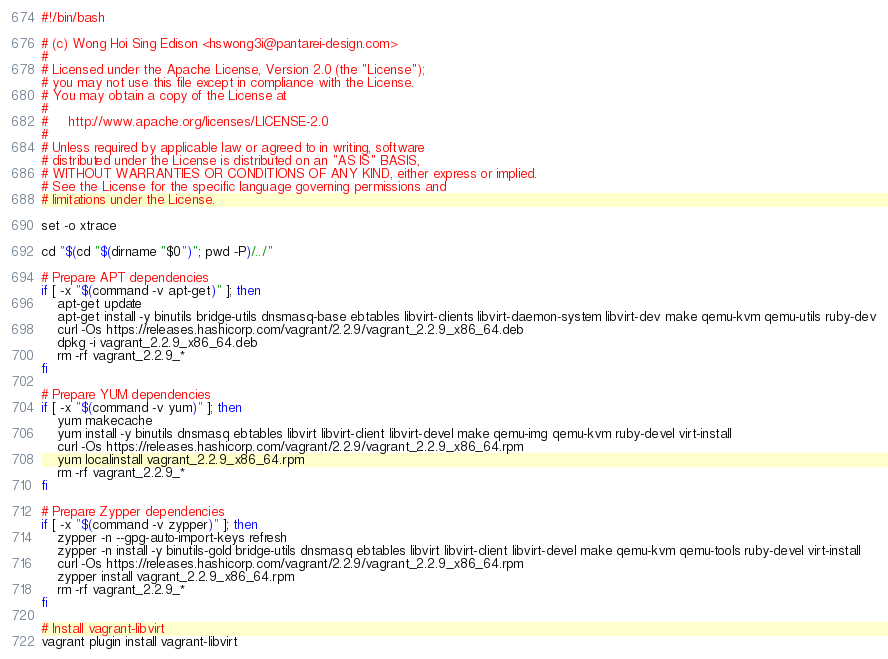Convert code to text. <code><loc_0><loc_0><loc_500><loc_500><_Bash_>#!/bin/bash

# (c) Wong Hoi Sing Edison <hswong3i@pantarei-design.com>
#
# Licensed under the Apache License, Version 2.0 (the "License");
# you may not use this file except in compliance with the License.
# You may obtain a copy of the License at
#
#     http://www.apache.org/licenses/LICENSE-2.0
#
# Unless required by applicable law or agreed to in writing, software
# distributed under the License is distributed on an "AS IS" BASIS,
# WITHOUT WARRANTIES OR CONDITIONS OF ANY KIND, either express or implied.
# See the License for the specific language governing permissions and
# limitations under the License.

set -o xtrace

cd "$(cd "$(dirname "$0")"; pwd -P)/../"

# Prepare APT dependencies
if [ -x "$(command -v apt-get)" ]; then
    apt-get update
    apt-get install -y binutils bridge-utils dnsmasq-base ebtables libvirt-clients libvirt-daemon-system libvirt-dev make qemu-kvm qemu-utils ruby-dev
    curl -Os https://releases.hashicorp.com/vagrant/2.2.9/vagrant_2.2.9_x86_64.deb
    dpkg -i vagrant_2.2.9_x86_64.deb
    rm -rf vagrant_2.2.9_*
fi

# Prepare YUM dependencies
if [ -x "$(command -v yum)" ]; then
    yum makecache
    yum install -y binutils dnsmasq ebtables libvirt libvirt-client libvirt-devel make qemu-img qemu-kvm ruby-devel virt-install
    curl -Os https://releases.hashicorp.com/vagrant/2.2.9/vagrant_2.2.9_x86_64.rpm
    yum localinstall vagrant_2.2.9_x86_64.rpm
    rm -rf vagrant_2.2.9_*
fi

# Prepare Zypper dependencies
if [ -x "$(command -v zypper)" ]; then
    zypper -n --gpg-auto-import-keys refresh
    zypper -n install -y binutils-gold bridge-utils dnsmasq ebtables libvirt libvirt-client libvirt-devel make qemu-kvm qemu-tools ruby-devel virt-install
    curl -Os https://releases.hashicorp.com/vagrant/2.2.9/vagrant_2.2.9_x86_64.rpm
    zypper install vagrant_2.2.9_x86_64.rpm
    rm -rf vagrant_2.2.9_*
fi

# Install vagrant-libvirt
vagrant plugin install vagrant-libvirt
</code> 